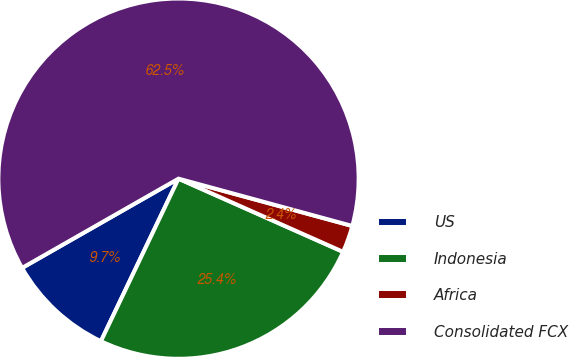Convert chart to OTSL. <chart><loc_0><loc_0><loc_500><loc_500><pie_chart><fcel>US<fcel>Indonesia<fcel>Africa<fcel>Consolidated FCX<nl><fcel>9.66%<fcel>25.43%<fcel>2.43%<fcel>62.49%<nl></chart> 